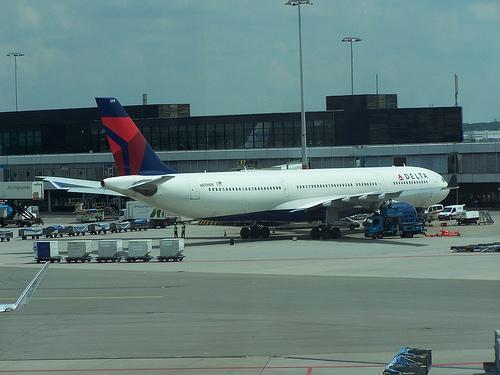How many doors are seen on this side of the plane?
Give a very brief answer. 3. How many planes are completely visible?
Give a very brief answer. 1. 